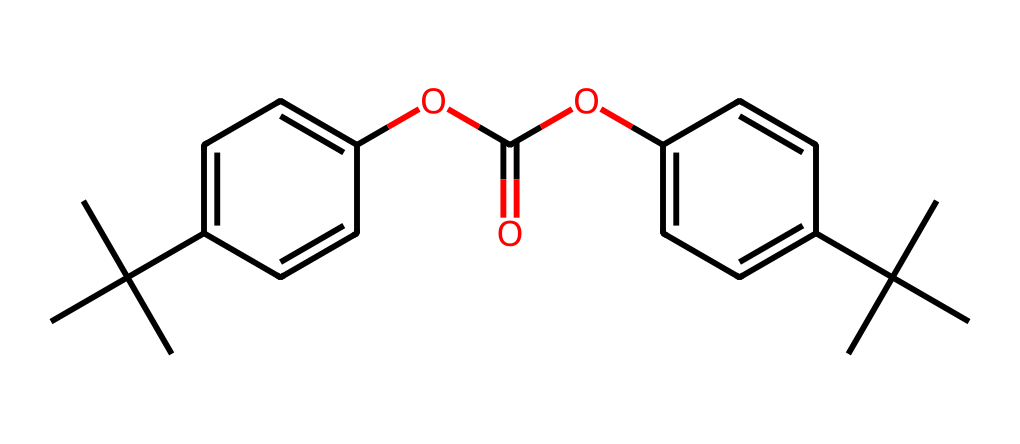What is the functional group present in this chemical? The chemical has an ester functional group, which can be identified by the presence of the -O-C(=O)- moiety in the structure. This is a characteristic feature of esters, which consists of a carbonyl (C=O) bonded to an oxygen atom (O) and another carbon chain.
Answer: ester How many aromatic rings are present in this compound? By examining the structure, we can see that there are two distinct groups that contain a benzene ring, indicated by the presence of alternating double bonds in cyclic arrangements. Therefore, the number of aromatic rings is two.
Answer: two What is the total number of carbon atoms in the structure? The carbon backbone of the chemical is determined by counting all the carbon atoms present in the structure, including those in the alkyl groups and aromatic rings. In this case, there are 24 carbon atoms.
Answer: twenty-four What type of polymerization process is generally used to produce polycarbonate? Polycarbonate is typically produced through a process called condensation polymerization, where monomers join while releasing small molecules, often water. This process facilitates the formation of the polycarbonate chains characteristic of the material.
Answer: condensation Is this compound likely to be biodegradable? Given that polycarbonate is derived from a synthetic process and is a type of plastic consisting of repeating ester linkages, it is generally non-biodegradable under natural conditions. This is a significant environmental concern associated with the use of polycarbonate plastics.
Answer: no What property makes polycarbonate suitable for safety glasses? Polycarbonate has a high impact resistance due to its unique molecular structure, which absorbs energy and disperses it across the material, protecting against shattering. This property is crucial for materials used in protective equipment.
Answer: impact resistance 